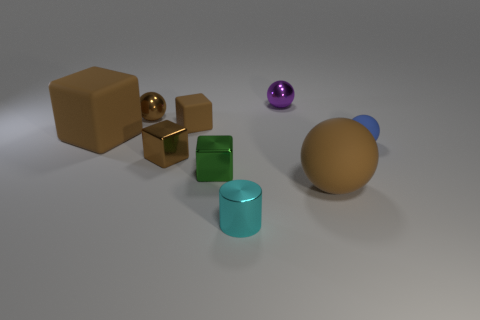What shape is the purple thing that is the same size as the cylinder?
Give a very brief answer. Sphere. Is there a brown object of the same shape as the green thing?
Ensure brevity in your answer.  Yes. Does the brown sphere that is on the right side of the green cube have the same size as the small purple thing?
Ensure brevity in your answer.  No. What is the size of the ball that is behind the large sphere and in front of the tiny brown metallic ball?
Keep it short and to the point. Small. What number of other things are made of the same material as the green thing?
Offer a terse response. 4. There is a brown sphere that is behind the small blue rubber object; what size is it?
Your answer should be compact. Small. Do the big block and the big rubber sphere have the same color?
Provide a succinct answer. Yes. What number of tiny things are brown rubber balls or yellow spheres?
Give a very brief answer. 0. Is there any other thing of the same color as the tiny rubber cube?
Make the answer very short. Yes. Are there any small brown things on the right side of the small matte sphere?
Ensure brevity in your answer.  No. 